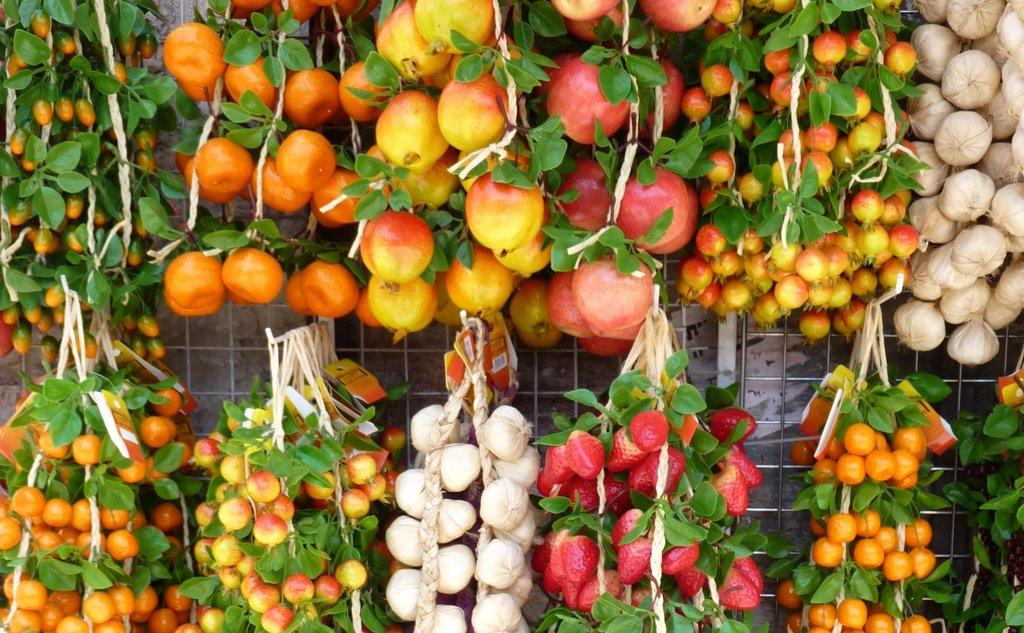What is the main subject of the image? The main subject of the image is a bunch of fruits. How are the fruits arranged or displayed in the image? The fruits are hanging with the help of a white color rope. What type of harbor can be seen in the image? There is no harbor present in the image; it features a bunch of fruits hanging with a white color rope. What selection of fruits is available in the image? The image only shows a bunch of fruits hanging with a white color rope, so it is not possible to determine the specific selection of fruits. 